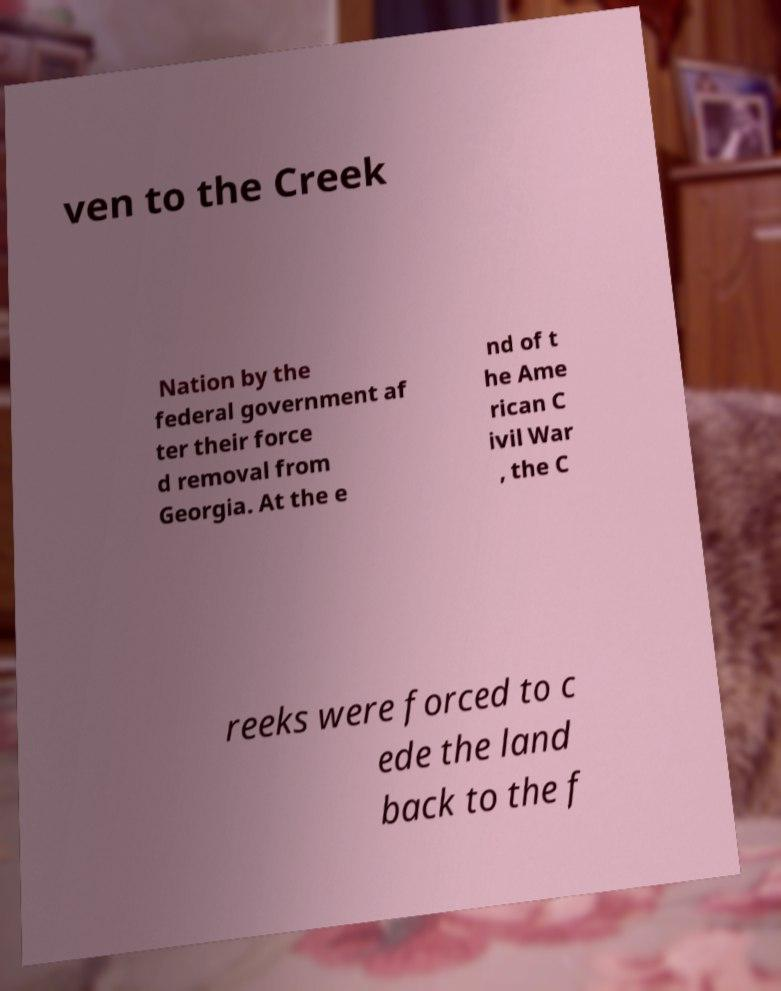There's text embedded in this image that I need extracted. Can you transcribe it verbatim? ven to the Creek Nation by the federal government af ter their force d removal from Georgia. At the e nd of t he Ame rican C ivil War , the C reeks were forced to c ede the land back to the f 